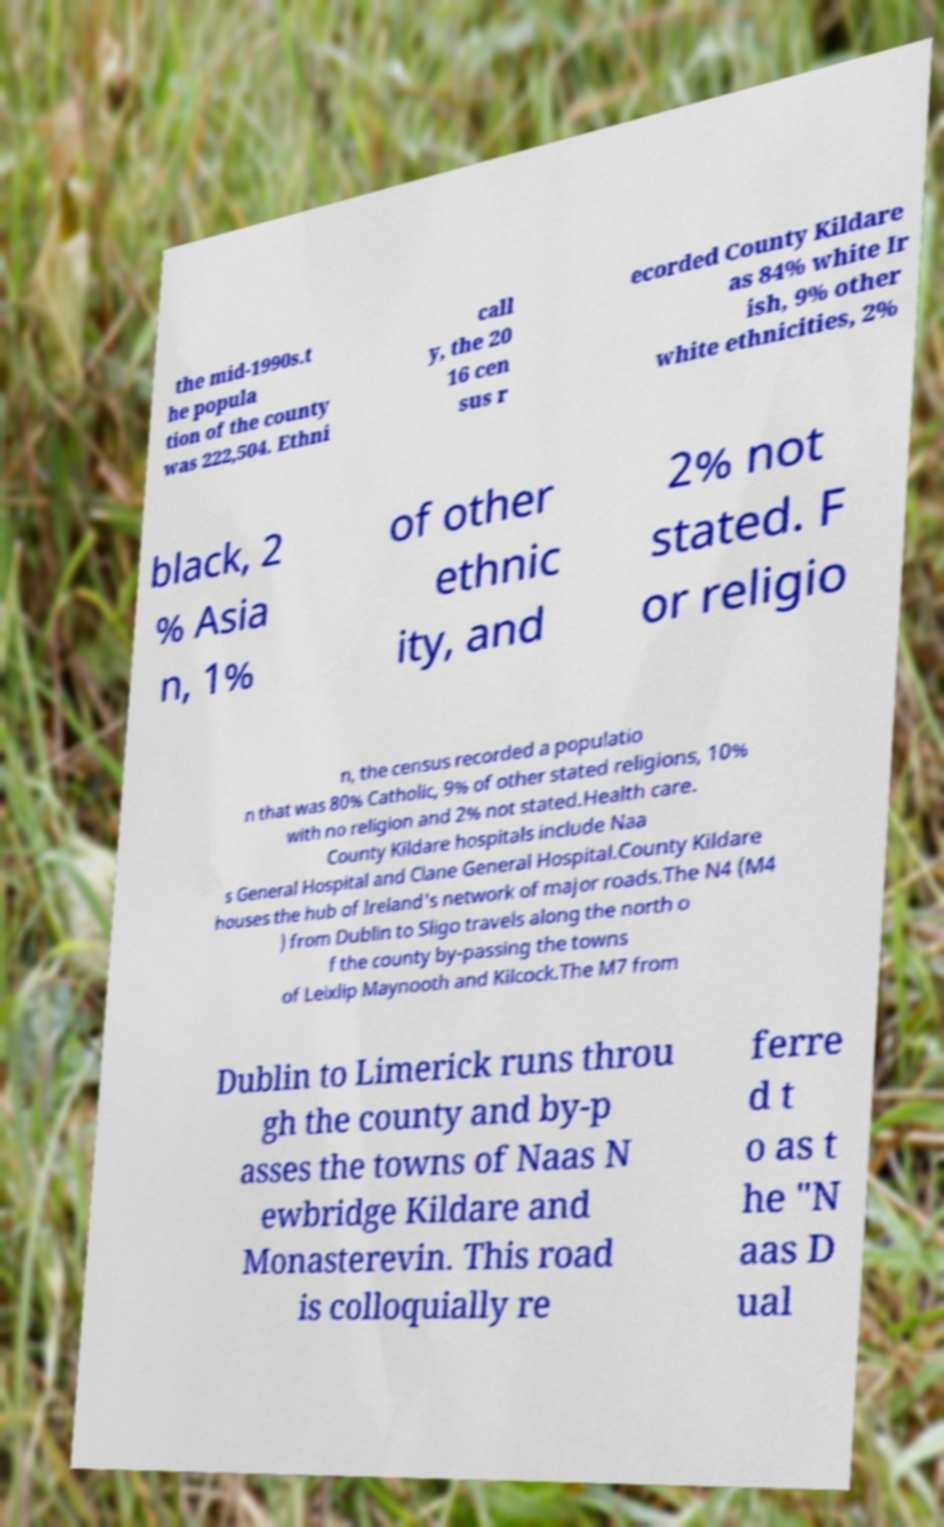Can you read and provide the text displayed in the image?This photo seems to have some interesting text. Can you extract and type it out for me? the mid-1990s.t he popula tion of the county was 222,504. Ethni call y, the 20 16 cen sus r ecorded County Kildare as 84% white Ir ish, 9% other white ethnicities, 2% black, 2 % Asia n, 1% of other ethnic ity, and 2% not stated. F or religio n, the census recorded a populatio n that was 80% Catholic, 9% of other stated religions, 10% with no religion and 2% not stated.Health care. County Kildare hospitals include Naa s General Hospital and Clane General Hospital.County Kildare houses the hub of Ireland's network of major roads.The N4 (M4 ) from Dublin to Sligo travels along the north o f the county by-passing the towns of Leixlip Maynooth and Kilcock.The M7 from Dublin to Limerick runs throu gh the county and by-p asses the towns of Naas N ewbridge Kildare and Monasterevin. This road is colloquially re ferre d t o as t he "N aas D ual 